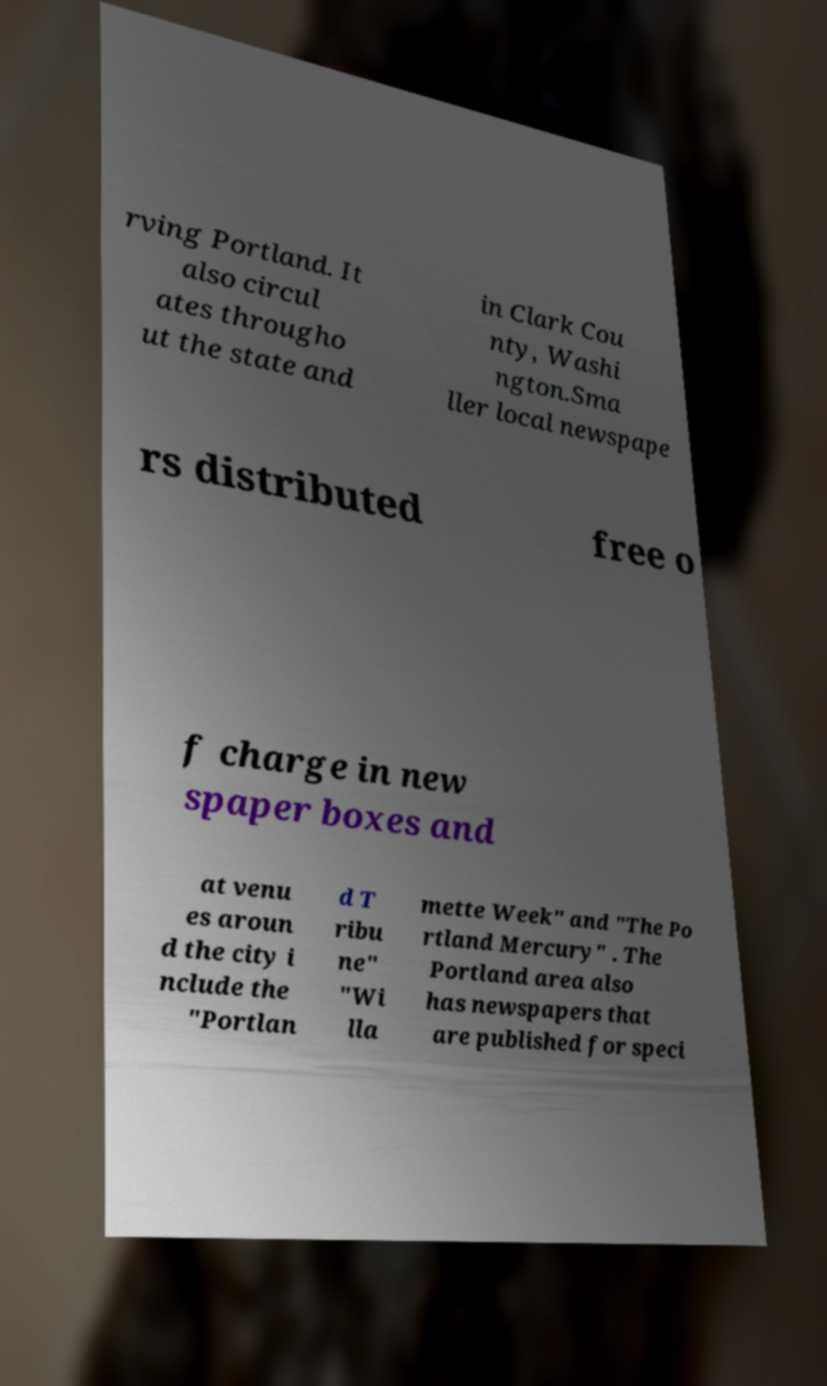Can you read and provide the text displayed in the image?This photo seems to have some interesting text. Can you extract and type it out for me? rving Portland. It also circul ates througho ut the state and in Clark Cou nty, Washi ngton.Sma ller local newspape rs distributed free o f charge in new spaper boxes and at venu es aroun d the city i nclude the "Portlan d T ribu ne" "Wi lla mette Week" and "The Po rtland Mercury" . The Portland area also has newspapers that are published for speci 